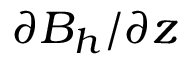Convert formula to latex. <formula><loc_0><loc_0><loc_500><loc_500>\partial B _ { h } / \partial z</formula> 